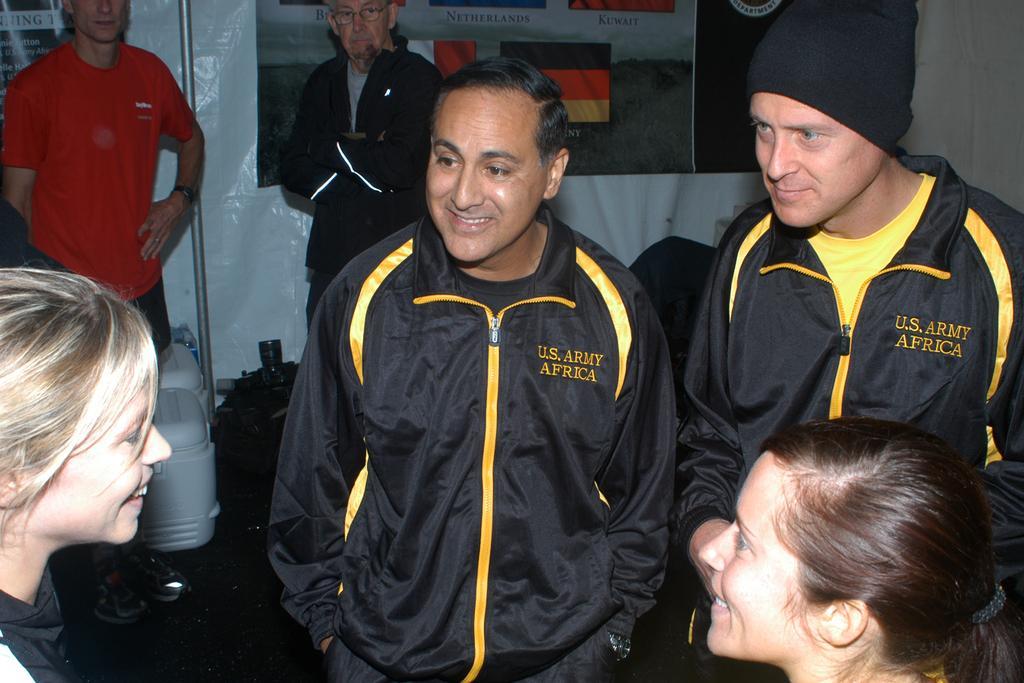Can you describe this image briefly? In the background we can see the banner, pole. We can see few objects on the floor. In this picture we can see the men. They are standing. At the bottom portion of the picture we can see the women and they are smiling. 